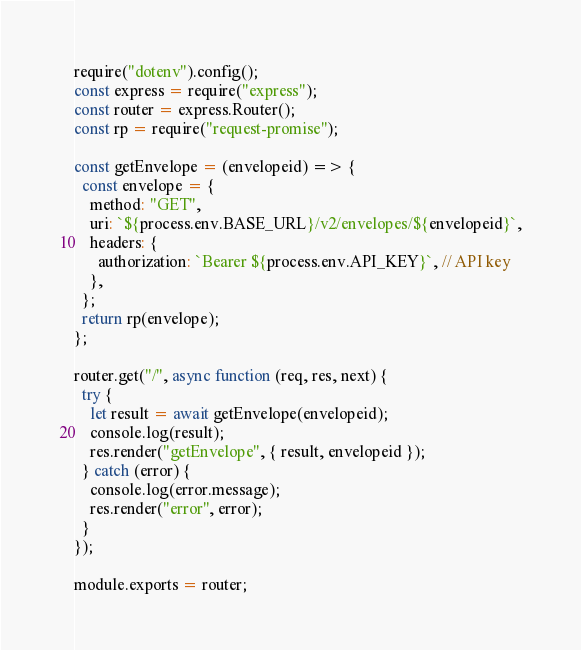Convert code to text. <code><loc_0><loc_0><loc_500><loc_500><_JavaScript_>require("dotenv").config();
const express = require("express");
const router = express.Router();
const rp = require("request-promise");

const getEnvelope = (envelopeid) => {
  const envelope = {
    method: "GET",
    uri: `${process.env.BASE_URL}/v2/envelopes/${envelopeid}`,
    headers: {
      authorization: `Bearer ${process.env.API_KEY}`, // API key
    },
  };
  return rp(envelope);
};

router.get("/", async function (req, res, next) {
  try {
    let result = await getEnvelope(envelopeid);
    console.log(result);
    res.render("getEnvelope", { result, envelopeid });
  } catch (error) {
    console.log(error.message);
    res.render("error", error);
  }
});

module.exports = router;
</code> 